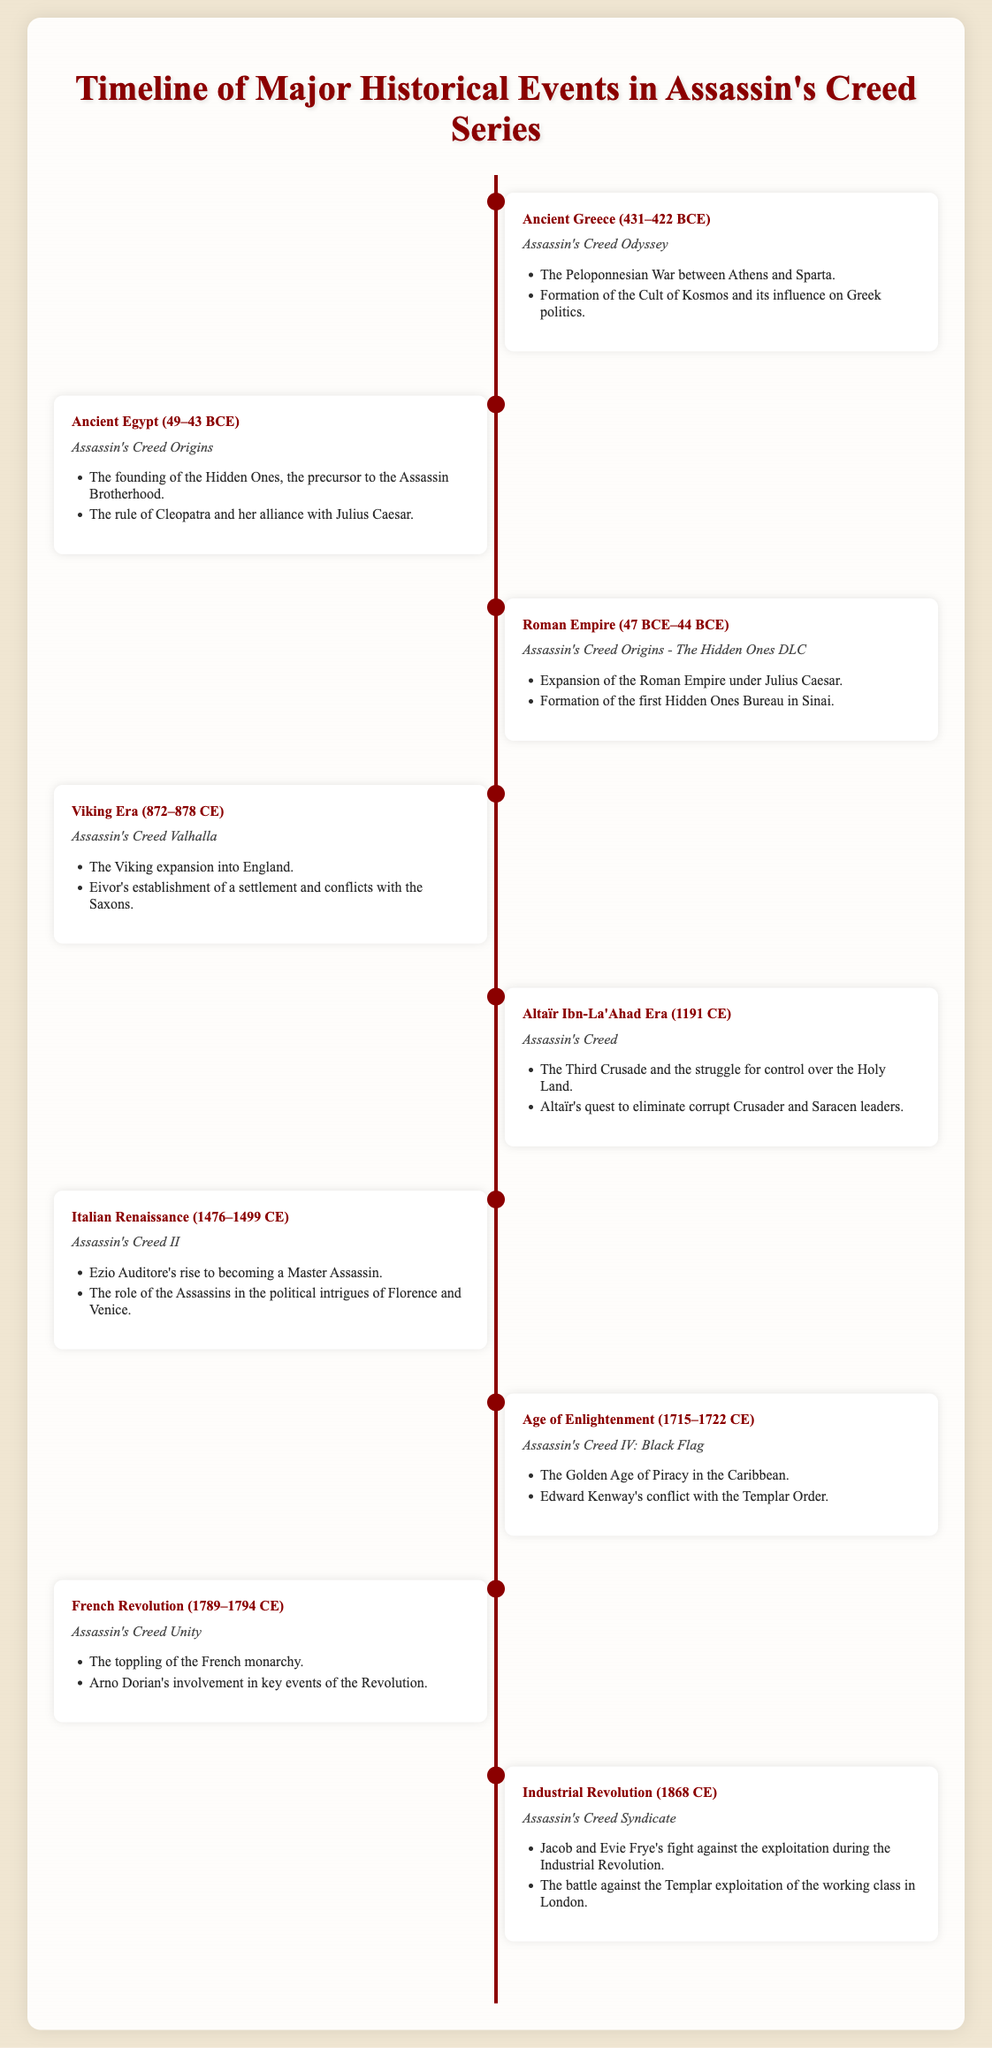What is the time period of the Peloponnesian War? The Peloponnesian War lasted from 431 to 422 BCE, as stated in the event about Ancient Greece.
Answer: 431–422 BCE Which game features the founding of the Hidden Ones? The founding of the Hidden Ones is a key event in Assassin's Creed Origins, as noted in the Ancient Egypt event.
Answer: Assassin's Creed Origins During which historical period does Ezio Auditore rise to power? The event concerning Ezio Auditore mentions the Italian Renaissance from 1476 to 1499 CE.
Answer: 1476–1499 CE What major event is associated with Arno Dorian? Arno Dorian is closely associated with the French Revolution as indicated in the relevant timeline event.
Answer: French Revolution How many events in total are listed in the timeline? There are eight major historical events outlined in the timeline of the Assassin's Creed series.
Answer: Eight What significant conflict is highlighted in Assassin's Creed Valhalla? The Viking expansion into England is a significant conflict highlighted in Assassin's Creed Valhalla.
Answer: Viking expansion Which era is represented by Altaïr Ibn-La'Ahad? Altaïr Ibn-La'Ahad is set during the era of the Third Crusade in 1191 CE.
Answer: 1191 CE What influenced politics in Ancient Greece according to the document? The Cult of Kosmos influenced Greek politics during the Peloponnesian War.
Answer: Cult of Kosmos Which character is involved in the establishment of a settlement? Eivor is the character noted for establishing a settlement during the Viking Era in Assassin's Creed Valhalla.
Answer: Eivor 